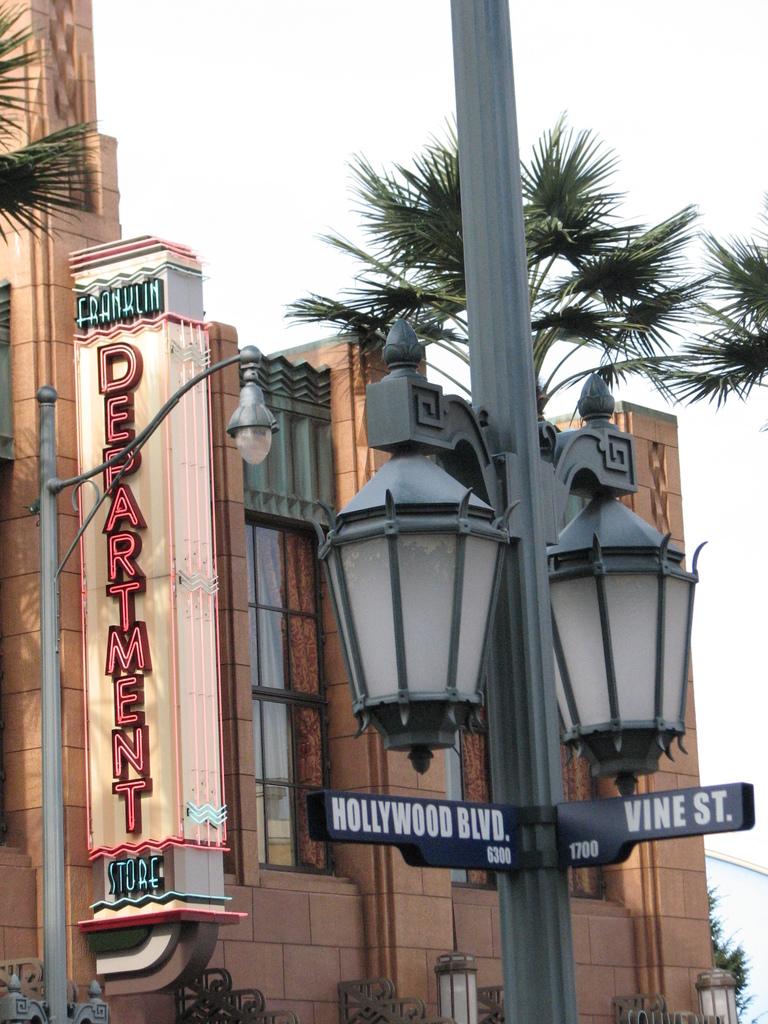What is the street on the right?
Provide a succinct answer. Vine st. 